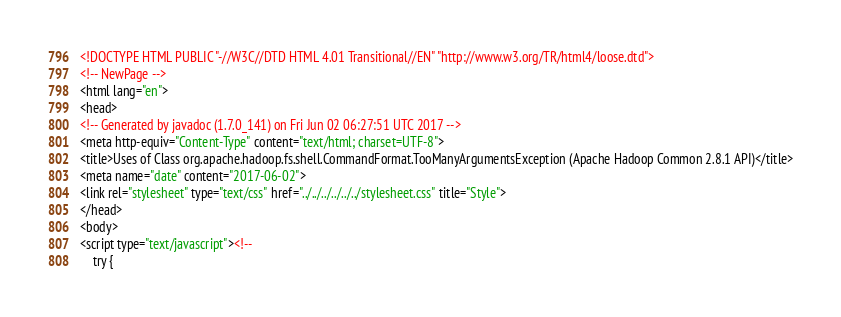Convert code to text. <code><loc_0><loc_0><loc_500><loc_500><_HTML_><!DOCTYPE HTML PUBLIC "-//W3C//DTD HTML 4.01 Transitional//EN" "http://www.w3.org/TR/html4/loose.dtd">
<!-- NewPage -->
<html lang="en">
<head>
<!-- Generated by javadoc (1.7.0_141) on Fri Jun 02 06:27:51 UTC 2017 -->
<meta http-equiv="Content-Type" content="text/html; charset=UTF-8">
<title>Uses of Class org.apache.hadoop.fs.shell.CommandFormat.TooManyArgumentsException (Apache Hadoop Common 2.8.1 API)</title>
<meta name="date" content="2017-06-02">
<link rel="stylesheet" type="text/css" href="../../../../../../stylesheet.css" title="Style">
</head>
<body>
<script type="text/javascript"><!--
    try {</code> 